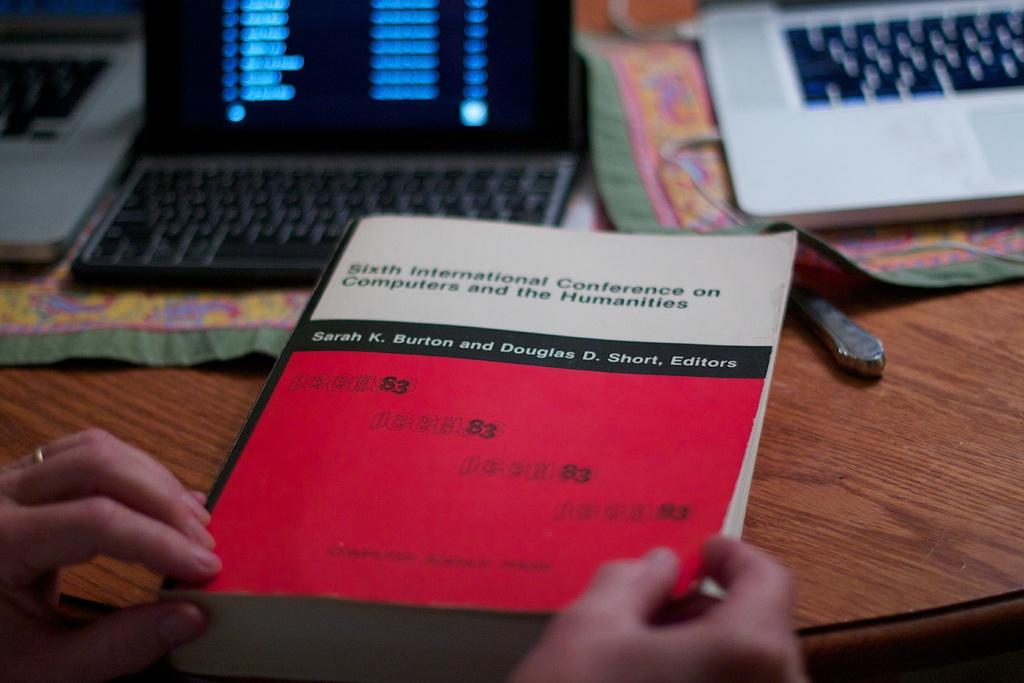<image>
Render a clear and concise summary of the photo. A person is holding a book about the sixth international conference on computers and the humanities. 